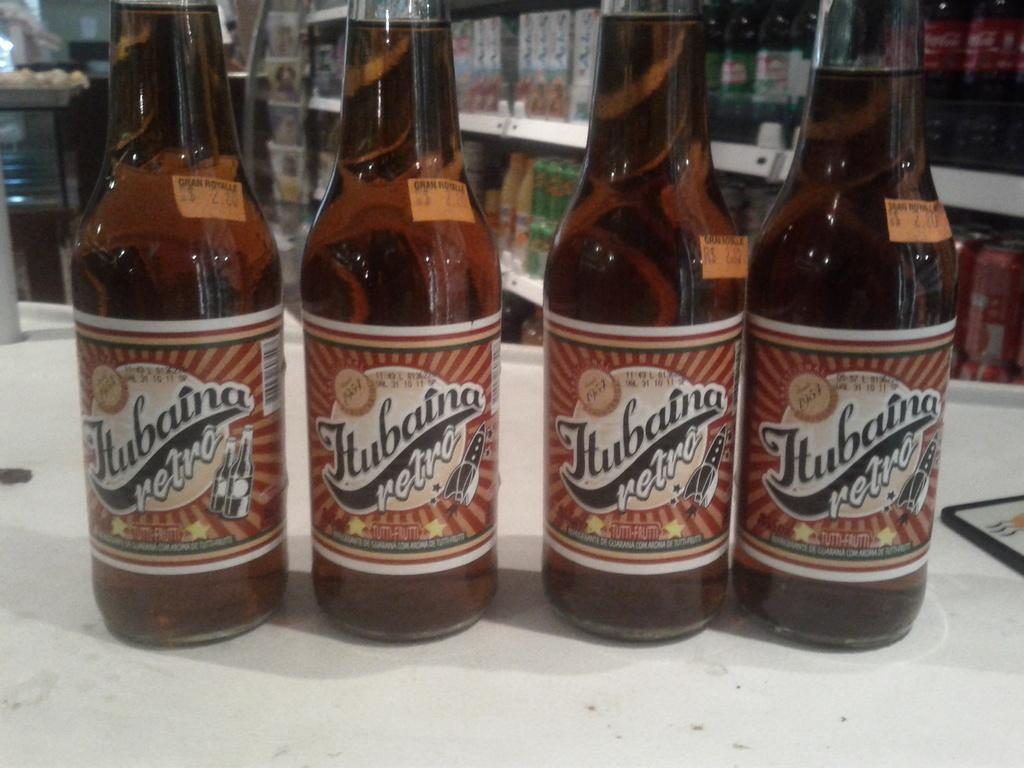Provide a one-sentence caption for the provided image. Four bottles of retro beer sit side by side on a counter. 